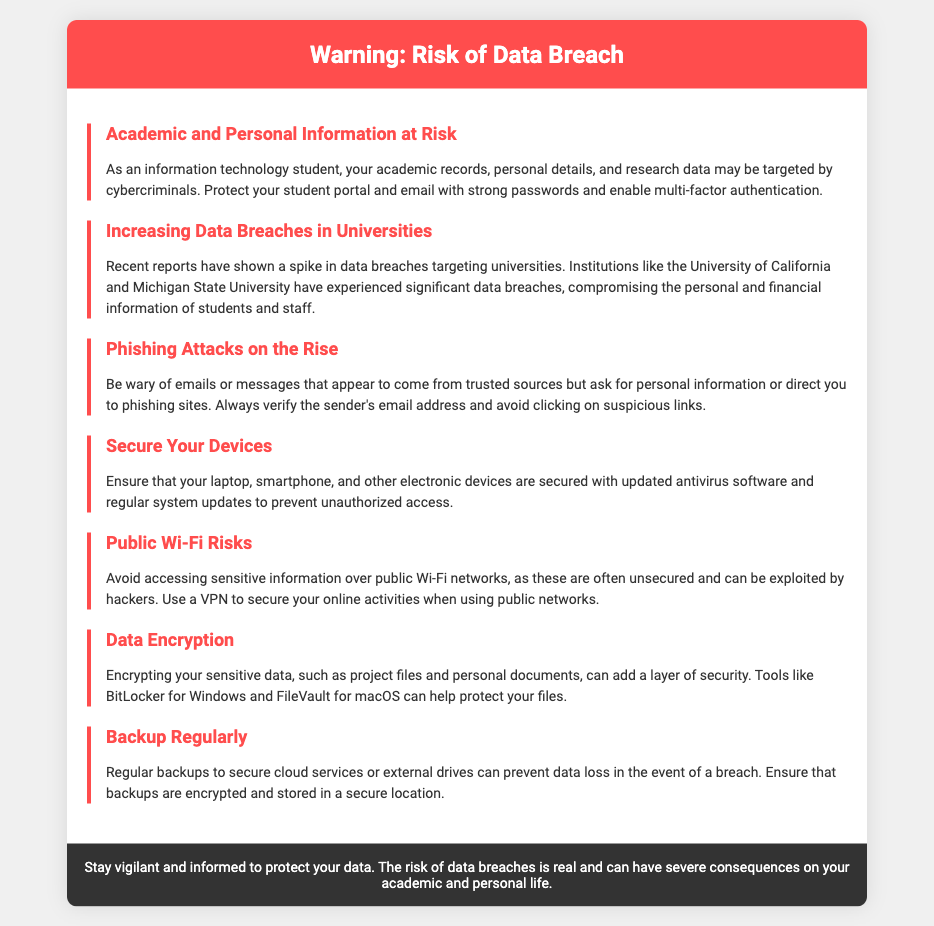What information is at risk? The document states that academic records, personal details, and research data are at risk.
Answer: Academic records, personal details, and research data Which universities experienced data breaches? The document mentions the University of California and Michigan State University as having significant data breaches.
Answer: University of California and Michigan State University What kind of attacks are on the rise according to the document? The document mentions phishing attacks as being on the rise.
Answer: Phishing attacks What should you use to secure your online activities over public Wi-Fi? It is recommended to use a VPN to secure online activities when using public networks.
Answer: VPN What tool can help encrypt sensitive data for Windows users? The document mentions BitLocker as a tool to help encrypt sensitive data for Windows users.
Answer: BitLocker Why should you backup your data regularly? Backing up data regularly can prevent data loss in the event of a breach.
Answer: Prevent data loss What is a recommended measure to protect your student portal? The document advises protecting your student portal with strong passwords and enabling multi-factor authentication.
Answer: Strong passwords and multi-factor authentication What is the primary focus of this warning label? The warning label focuses on the risk of data breaches affecting students.
Answer: Risk of data breaches How should sensitive information be accessed according to the document? It advises avoiding accessing sensitive information over public Wi-Fi networks.
Answer: Avoid public Wi-Fi 